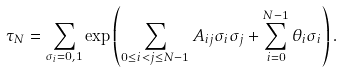Convert formula to latex. <formula><loc_0><loc_0><loc_500><loc_500>\tau _ { N } = \sum _ { \sigma _ { i } = 0 , 1 } \exp \left ( \sum _ { 0 \leq i < j \leq N - 1 } A _ { i j } \sigma _ { i } \sigma _ { j } + \sum _ { i = 0 } ^ { N - 1 } \theta _ { i } \sigma _ { i } \right ) .</formula> 